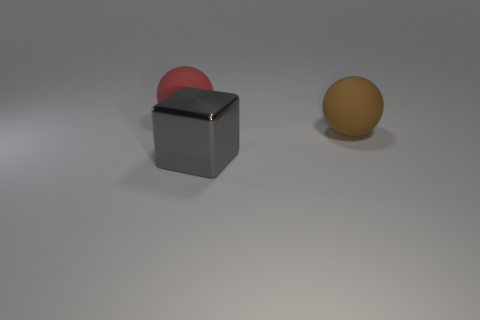Could you describe the texture of the objects shown? The surface of the gray cube seems to have a matte finish with slight specular highlights, indicating a relatively smooth but not highly reflective texture. The red and pink sphere shows a soft, slightly reflective surface without apparent roughness. The yellowish-orange sphere has a uniform, matte surface similar to the cube but with a different color. 